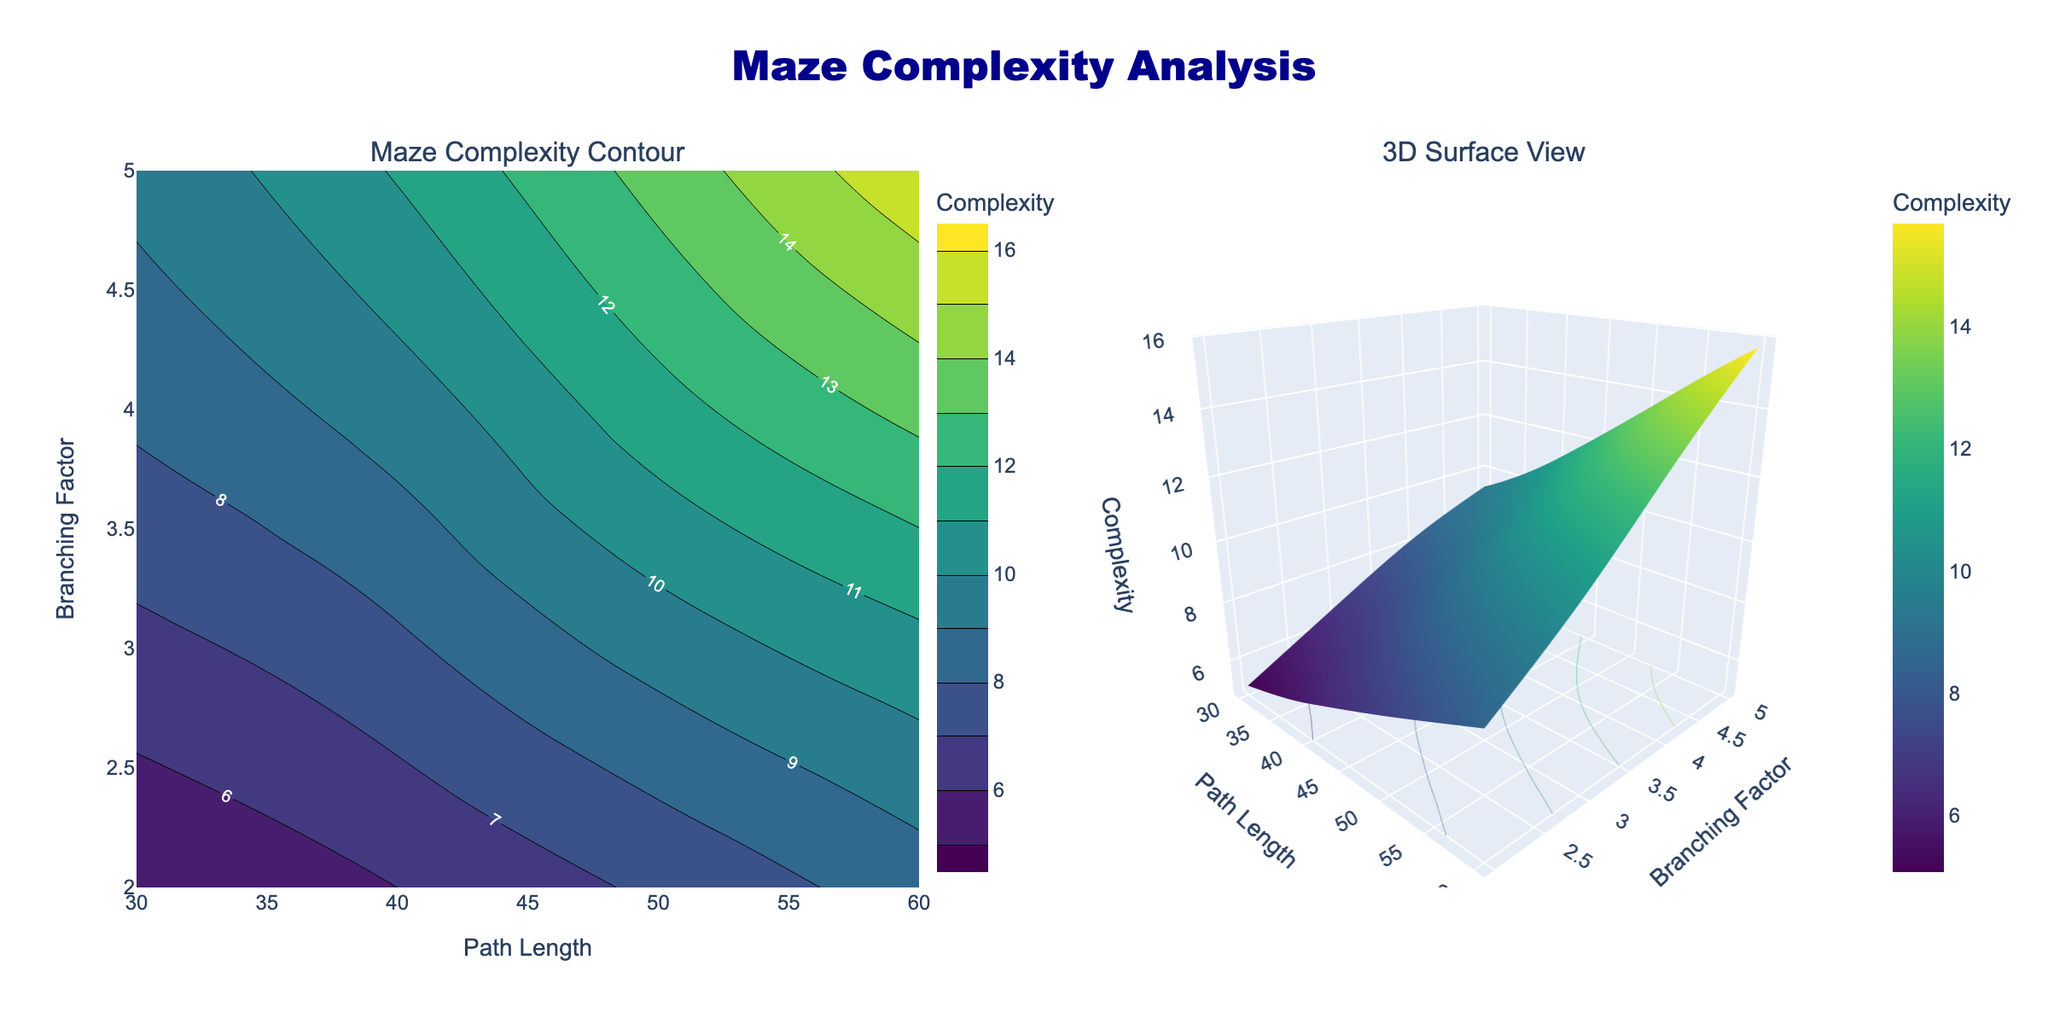What is the title of the figure? The title is located at the top center of the figure, which is styled with the font "Arial Black" in dark blue. The title reads "Maze Complexity Analysis."
Answer: Maze Complexity Analysis What are the labels for the X-axis and Y-axis in the contour plot? The labels for the axes are found at the bottom and left of the contour plot. The X-axis is labeled "Path Length," and the Y-axis is labeled "Branching Factor."
Answer: Path Length, Branching Factor What is the range of complexity values indicated by the color bar in the contour plot? The color bar to the right of the contour plot shows the range of complexity values. It starts at 5 and ends at 16.
Answer: 5 to 16 Which path length and branching factor combination results in the highest complexity in the contour plot, and what is that complexity value? In the contour plot, the highest complexity is at the top right corner where the path length is 60 and the branching factor is 5, with the complexity value exceeding 15.
Answer: Path length 60 and branching factor 5, complexity exceeding 15 How would you describe the relationship between path length and complexity as seen in the contour plot, considering a fixed branching factor? As you move horizontally along the contour plot (keeping branching factor constant), the contour lines indicate that the complexity values increase as path length increases. This suggests a positive relationship between path length and complexity.
Answer: Positive relationship What is the complexity difference when the branching factor changes from 2 to 5 for a constant path length of 50? For path length 50, the complexity values at branching factors 2 and 5 can be identified from the contour plot as around 7.2 and 13.4, respectively. The difference is calculated by subtracting the lower value from the higher value: 13.4 - 7.2 = 6.2.
Answer: 6.2 What are the specific colors representing the lowest and highest complexity values in the contour plot? The colors are derived from the Viridis colorscale, where the lowest complexity value (5) is a dark purple and the highest complexity value (16) is a bright yellow.
Answer: Dark purple and bright yellow How does the complexity change as both path length and branching factor simultaneously increase? Observing diagonal upward movement from the bottom left to the top right of the contour plot, the contour lines indicate a clear trend of increasing complexity. Thus, as both path length and branching factor increase, the complexity also increases.
Answer: Increases What spatial feature in the 3D surface plot represents the highest complexity values, and where is it located? In the 3D surface plot, the highest complexity values are represented by peaks on the surface. These peaks are located at the area where path length is highest (60) and the branching factor is highest (5).
Answer: Peaks at path length 60 and branching factor 5 Do the contour lines in the contour plot form any closed loops, and what does this indicate about complexity? Yes, some contour lines form closed loops in the contour plot. Closed loops indicate regions with approximately the same complexity, suggesting an area of relative stability or distinct regions separated by varying complexity.
Answer: Yes, indicate areas of stability 